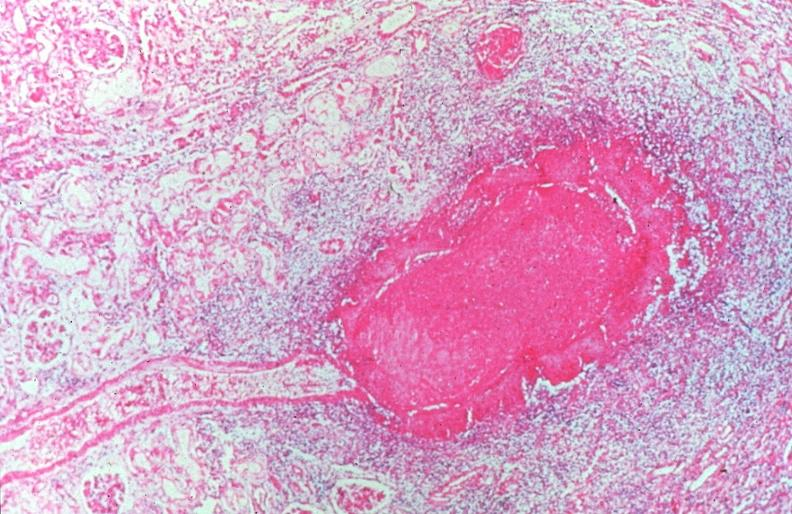does this image show vasculitis, polyarteritis nodosa?
Answer the question using a single word or phrase. Yes 